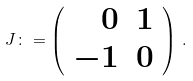Convert formula to latex. <formula><loc_0><loc_0><loc_500><loc_500>J \colon = \left ( \begin{array} { r r } 0 & 1 \\ - 1 & 0 \\ \end{array} \right ) \, .</formula> 